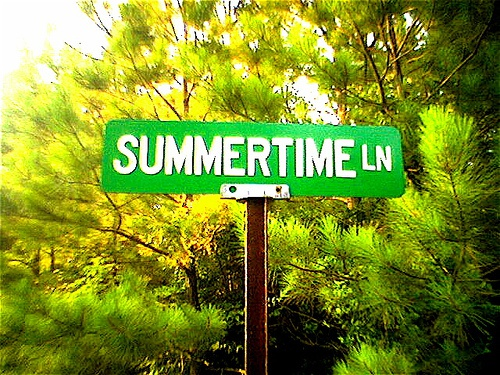Describe the objects in this image and their specific colors. I can see various objects in this image with different colors. 